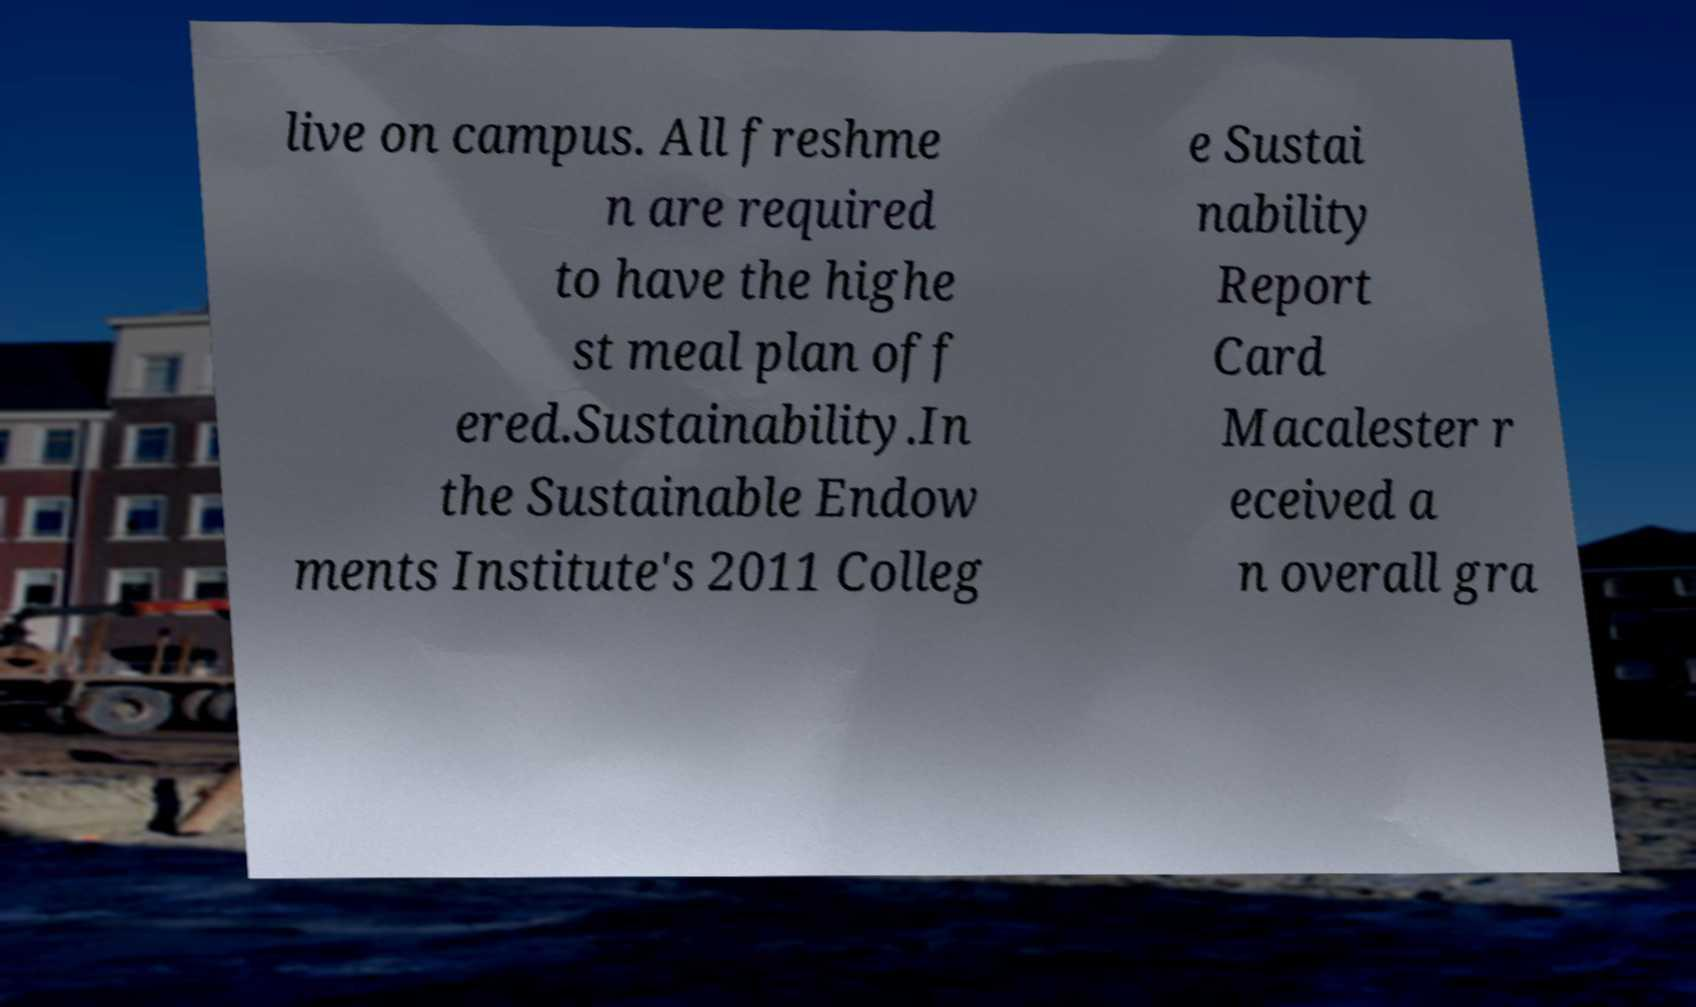There's text embedded in this image that I need extracted. Can you transcribe it verbatim? live on campus. All freshme n are required to have the highe st meal plan off ered.Sustainability.In the Sustainable Endow ments Institute's 2011 Colleg e Sustai nability Report Card Macalester r eceived a n overall gra 